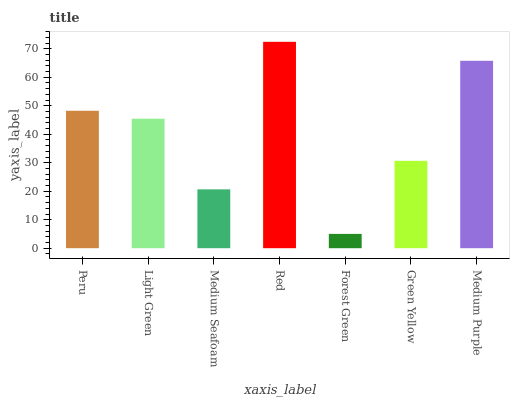Is Forest Green the minimum?
Answer yes or no. Yes. Is Red the maximum?
Answer yes or no. Yes. Is Light Green the minimum?
Answer yes or no. No. Is Light Green the maximum?
Answer yes or no. No. Is Peru greater than Light Green?
Answer yes or no. Yes. Is Light Green less than Peru?
Answer yes or no. Yes. Is Light Green greater than Peru?
Answer yes or no. No. Is Peru less than Light Green?
Answer yes or no. No. Is Light Green the high median?
Answer yes or no. Yes. Is Light Green the low median?
Answer yes or no. Yes. Is Forest Green the high median?
Answer yes or no. No. Is Medium Seafoam the low median?
Answer yes or no. No. 